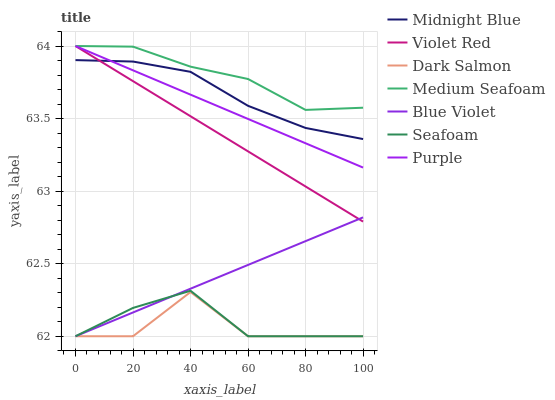Does Dark Salmon have the minimum area under the curve?
Answer yes or no. Yes. Does Medium Seafoam have the maximum area under the curve?
Answer yes or no. Yes. Does Midnight Blue have the minimum area under the curve?
Answer yes or no. No. Does Midnight Blue have the maximum area under the curve?
Answer yes or no. No. Is Purple the smoothest?
Answer yes or no. Yes. Is Dark Salmon the roughest?
Answer yes or no. Yes. Is Midnight Blue the smoothest?
Answer yes or no. No. Is Midnight Blue the roughest?
Answer yes or no. No. Does Seafoam have the lowest value?
Answer yes or no. Yes. Does Midnight Blue have the lowest value?
Answer yes or no. No. Does Medium Seafoam have the highest value?
Answer yes or no. Yes. Does Midnight Blue have the highest value?
Answer yes or no. No. Is Seafoam less than Midnight Blue?
Answer yes or no. Yes. Is Purple greater than Blue Violet?
Answer yes or no. Yes. Does Blue Violet intersect Dark Salmon?
Answer yes or no. Yes. Is Blue Violet less than Dark Salmon?
Answer yes or no. No. Is Blue Violet greater than Dark Salmon?
Answer yes or no. No. Does Seafoam intersect Midnight Blue?
Answer yes or no. No. 